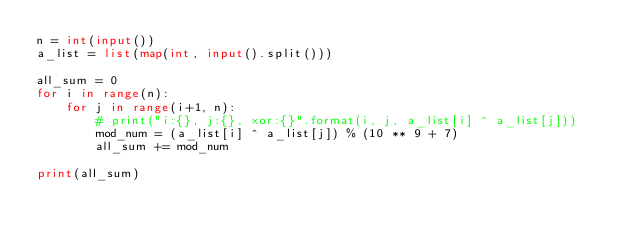<code> <loc_0><loc_0><loc_500><loc_500><_Python_>n = int(input())
a_list = list(map(int, input().split()))

all_sum = 0
for i in range(n):
    for j in range(i+1, n):
        # print("i:{}, j:{}, xor:{}".format(i, j, a_list[i] ^ a_list[j]))
        mod_num = (a_list[i] ^ a_list[j]) % (10 ** 9 + 7)
        all_sum += mod_num

print(all_sum)</code> 